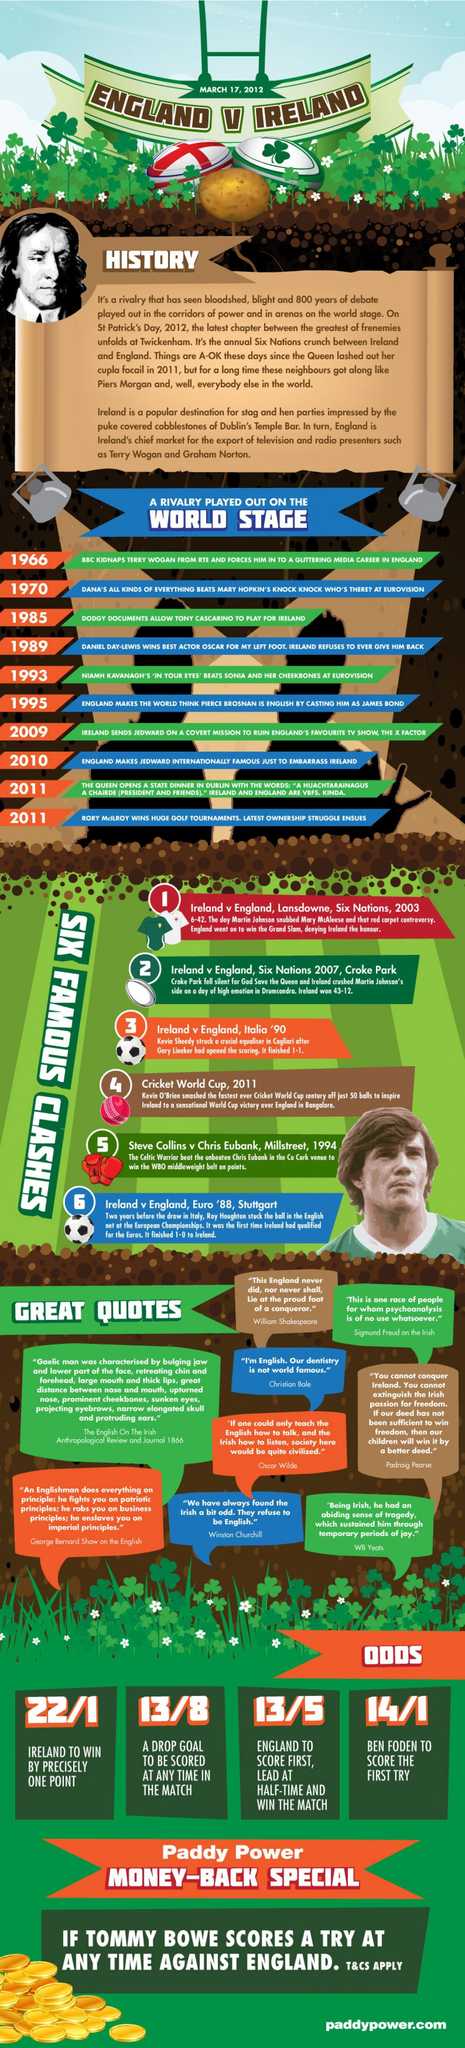What was the score of England when they lead at half time and win the match?
Answer the question with a short phrase. 13/5 "This is one race of people for whom psychoanalysis is of no use whatsoever" -whose quote is this? Sigmund Freud How many wickets were gone when Ireland was about to win precisely by one point? 1 